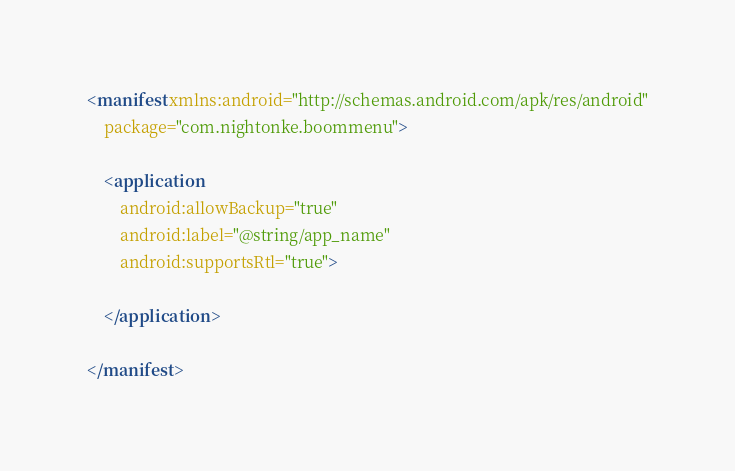<code> <loc_0><loc_0><loc_500><loc_500><_XML_><manifest xmlns:android="http://schemas.android.com/apk/res/android"
    package="com.nightonke.boommenu">

    <application
        android:allowBackup="true"
        android:label="@string/app_name"
        android:supportsRtl="true">

    </application>

</manifest>
</code> 